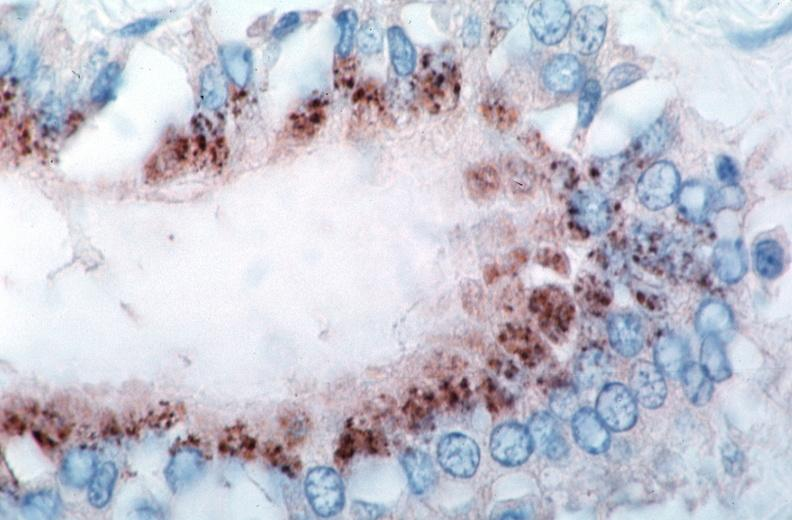does this image show vasculitis?
Answer the question using a single word or phrase. Yes 